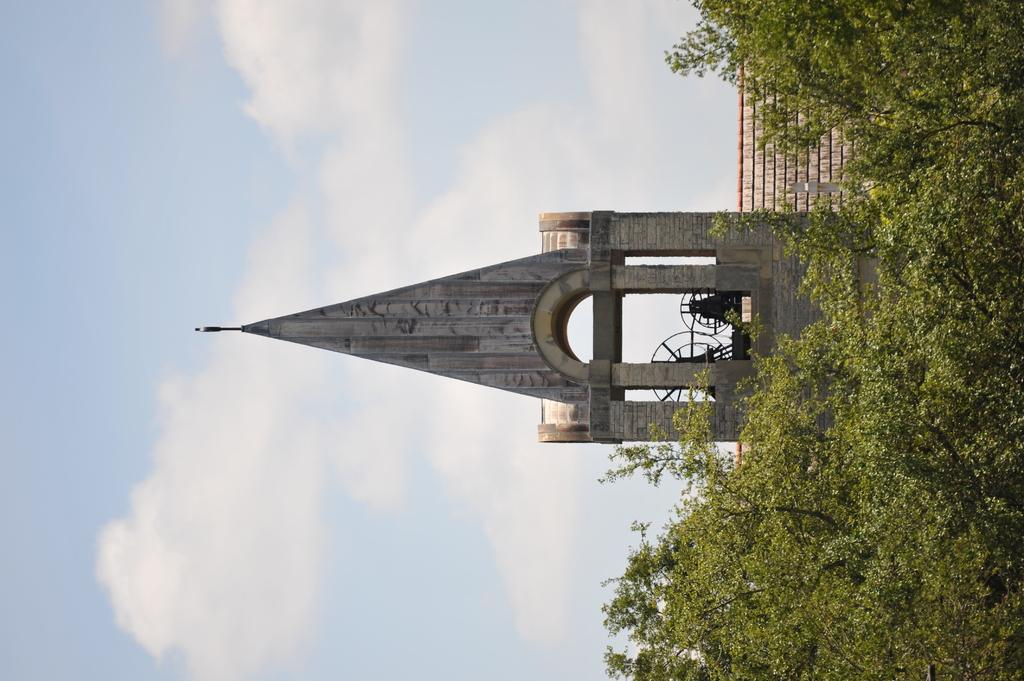What type of building is in the image? There is an arc building in the image. Are there any natural elements present in the image? Yes, there is a tree in the image. How would you describe the weather in the image? The sky is cloudy in the image, suggesting a potentially overcast or cloudy day. What type of soup is being served in the image? There is no soup present in the image; it features an arc building, a tree, and a cloudy sky. 